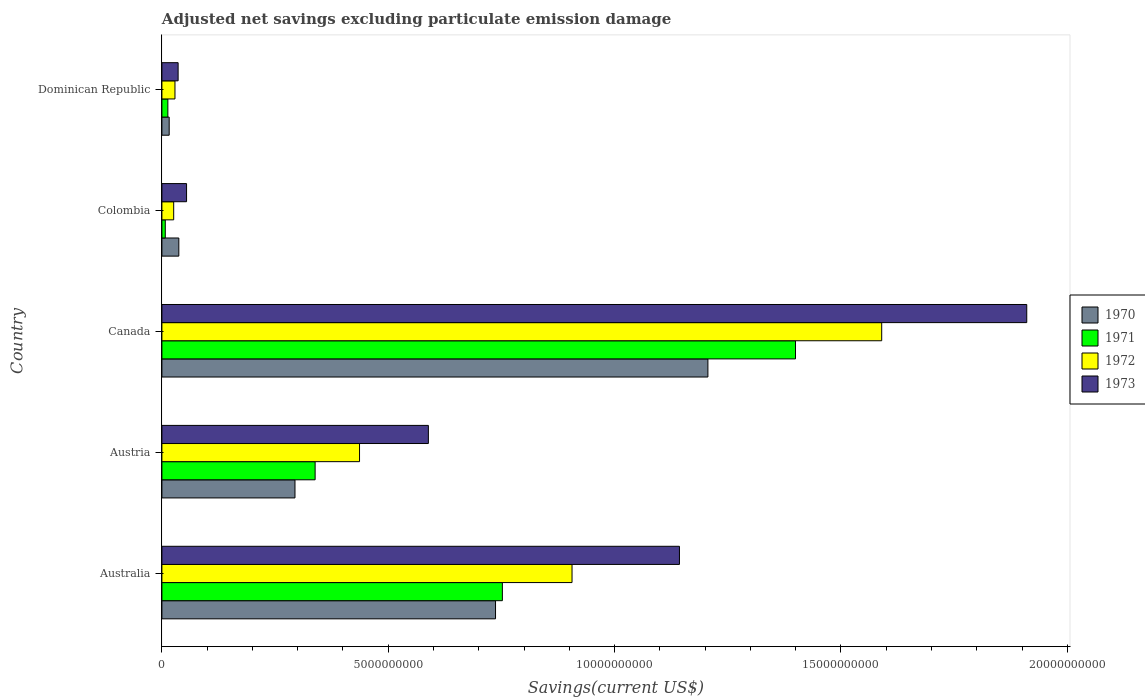How many groups of bars are there?
Provide a short and direct response. 5. Are the number of bars on each tick of the Y-axis equal?
Make the answer very short. Yes. How many bars are there on the 2nd tick from the top?
Provide a succinct answer. 4. How many bars are there on the 2nd tick from the bottom?
Give a very brief answer. 4. What is the label of the 2nd group of bars from the top?
Give a very brief answer. Colombia. What is the adjusted net savings in 1973 in Colombia?
Offer a terse response. 5.45e+08. Across all countries, what is the maximum adjusted net savings in 1973?
Your response must be concise. 1.91e+1. Across all countries, what is the minimum adjusted net savings in 1971?
Your answer should be very brief. 7.46e+07. In which country was the adjusted net savings in 1971 maximum?
Your answer should be compact. Canada. In which country was the adjusted net savings in 1970 minimum?
Your answer should be very brief. Dominican Republic. What is the total adjusted net savings in 1970 in the graph?
Your answer should be compact. 2.29e+1. What is the difference between the adjusted net savings in 1972 in Australia and that in Colombia?
Your answer should be very brief. 8.80e+09. What is the difference between the adjusted net savings in 1971 in Colombia and the adjusted net savings in 1972 in Australia?
Provide a succinct answer. -8.99e+09. What is the average adjusted net savings in 1973 per country?
Keep it short and to the point. 7.47e+09. What is the difference between the adjusted net savings in 1970 and adjusted net savings in 1971 in Colombia?
Make the answer very short. 2.99e+08. What is the ratio of the adjusted net savings in 1970 in Austria to that in Dominican Republic?
Your response must be concise. 18.25. Is the adjusted net savings in 1972 in Austria less than that in Canada?
Make the answer very short. Yes. What is the difference between the highest and the second highest adjusted net savings in 1973?
Offer a very short reply. 7.67e+09. What is the difference between the highest and the lowest adjusted net savings in 1972?
Ensure brevity in your answer.  1.56e+1. In how many countries, is the adjusted net savings in 1973 greater than the average adjusted net savings in 1973 taken over all countries?
Offer a very short reply. 2. Is it the case that in every country, the sum of the adjusted net savings in 1970 and adjusted net savings in 1973 is greater than the sum of adjusted net savings in 1972 and adjusted net savings in 1971?
Your answer should be very brief. No. Are all the bars in the graph horizontal?
Your response must be concise. Yes. Does the graph contain any zero values?
Provide a succinct answer. No. Does the graph contain grids?
Your answer should be compact. No. How many legend labels are there?
Provide a short and direct response. 4. How are the legend labels stacked?
Ensure brevity in your answer.  Vertical. What is the title of the graph?
Your response must be concise. Adjusted net savings excluding particulate emission damage. Does "1998" appear as one of the legend labels in the graph?
Your answer should be very brief. No. What is the label or title of the X-axis?
Provide a succinct answer. Savings(current US$). What is the label or title of the Y-axis?
Your answer should be compact. Country. What is the Savings(current US$) in 1970 in Australia?
Provide a succinct answer. 7.37e+09. What is the Savings(current US$) in 1971 in Australia?
Your answer should be very brief. 7.52e+09. What is the Savings(current US$) in 1972 in Australia?
Keep it short and to the point. 9.06e+09. What is the Savings(current US$) of 1973 in Australia?
Make the answer very short. 1.14e+1. What is the Savings(current US$) in 1970 in Austria?
Keep it short and to the point. 2.94e+09. What is the Savings(current US$) of 1971 in Austria?
Your answer should be compact. 3.38e+09. What is the Savings(current US$) of 1972 in Austria?
Ensure brevity in your answer.  4.37e+09. What is the Savings(current US$) in 1973 in Austria?
Provide a succinct answer. 5.89e+09. What is the Savings(current US$) in 1970 in Canada?
Provide a short and direct response. 1.21e+1. What is the Savings(current US$) of 1971 in Canada?
Provide a short and direct response. 1.40e+1. What is the Savings(current US$) in 1972 in Canada?
Your answer should be compact. 1.59e+1. What is the Savings(current US$) of 1973 in Canada?
Give a very brief answer. 1.91e+1. What is the Savings(current US$) in 1970 in Colombia?
Your response must be concise. 3.74e+08. What is the Savings(current US$) in 1971 in Colombia?
Your response must be concise. 7.46e+07. What is the Savings(current US$) of 1972 in Colombia?
Give a very brief answer. 2.60e+08. What is the Savings(current US$) of 1973 in Colombia?
Your answer should be very brief. 5.45e+08. What is the Savings(current US$) in 1970 in Dominican Republic?
Offer a very short reply. 1.61e+08. What is the Savings(current US$) in 1971 in Dominican Republic?
Make the answer very short. 1.32e+08. What is the Savings(current US$) in 1972 in Dominican Republic?
Keep it short and to the point. 2.89e+08. What is the Savings(current US$) in 1973 in Dominican Republic?
Offer a terse response. 3.58e+08. Across all countries, what is the maximum Savings(current US$) in 1970?
Your answer should be very brief. 1.21e+1. Across all countries, what is the maximum Savings(current US$) of 1971?
Provide a short and direct response. 1.40e+1. Across all countries, what is the maximum Savings(current US$) in 1972?
Keep it short and to the point. 1.59e+1. Across all countries, what is the maximum Savings(current US$) in 1973?
Your response must be concise. 1.91e+1. Across all countries, what is the minimum Savings(current US$) of 1970?
Provide a succinct answer. 1.61e+08. Across all countries, what is the minimum Savings(current US$) in 1971?
Ensure brevity in your answer.  7.46e+07. Across all countries, what is the minimum Savings(current US$) in 1972?
Make the answer very short. 2.60e+08. Across all countries, what is the minimum Savings(current US$) in 1973?
Offer a terse response. 3.58e+08. What is the total Savings(current US$) of 1970 in the graph?
Offer a very short reply. 2.29e+1. What is the total Savings(current US$) of 1971 in the graph?
Your answer should be compact. 2.51e+1. What is the total Savings(current US$) of 1972 in the graph?
Your answer should be very brief. 2.99e+1. What is the total Savings(current US$) in 1973 in the graph?
Your response must be concise. 3.73e+1. What is the difference between the Savings(current US$) in 1970 in Australia and that in Austria?
Ensure brevity in your answer.  4.43e+09. What is the difference between the Savings(current US$) in 1971 in Australia and that in Austria?
Offer a very short reply. 4.14e+09. What is the difference between the Savings(current US$) in 1972 in Australia and that in Austria?
Give a very brief answer. 4.69e+09. What is the difference between the Savings(current US$) in 1973 in Australia and that in Austria?
Give a very brief answer. 5.55e+09. What is the difference between the Savings(current US$) in 1970 in Australia and that in Canada?
Make the answer very short. -4.69e+09. What is the difference between the Savings(current US$) of 1971 in Australia and that in Canada?
Your answer should be compact. -6.48e+09. What is the difference between the Savings(current US$) in 1972 in Australia and that in Canada?
Your response must be concise. -6.84e+09. What is the difference between the Savings(current US$) in 1973 in Australia and that in Canada?
Ensure brevity in your answer.  -7.67e+09. What is the difference between the Savings(current US$) in 1970 in Australia and that in Colombia?
Your response must be concise. 7.00e+09. What is the difference between the Savings(current US$) of 1971 in Australia and that in Colombia?
Your response must be concise. 7.45e+09. What is the difference between the Savings(current US$) in 1972 in Australia and that in Colombia?
Your answer should be very brief. 8.80e+09. What is the difference between the Savings(current US$) in 1973 in Australia and that in Colombia?
Your answer should be very brief. 1.09e+1. What is the difference between the Savings(current US$) of 1970 in Australia and that in Dominican Republic?
Provide a short and direct response. 7.21e+09. What is the difference between the Savings(current US$) of 1971 in Australia and that in Dominican Republic?
Your answer should be compact. 7.39e+09. What is the difference between the Savings(current US$) of 1972 in Australia and that in Dominican Republic?
Make the answer very short. 8.77e+09. What is the difference between the Savings(current US$) in 1973 in Australia and that in Dominican Republic?
Offer a very short reply. 1.11e+1. What is the difference between the Savings(current US$) in 1970 in Austria and that in Canada?
Give a very brief answer. -9.12e+09. What is the difference between the Savings(current US$) in 1971 in Austria and that in Canada?
Offer a terse response. -1.06e+1. What is the difference between the Savings(current US$) in 1972 in Austria and that in Canada?
Ensure brevity in your answer.  -1.15e+1. What is the difference between the Savings(current US$) of 1973 in Austria and that in Canada?
Make the answer very short. -1.32e+1. What is the difference between the Savings(current US$) in 1970 in Austria and that in Colombia?
Offer a terse response. 2.57e+09. What is the difference between the Savings(current US$) in 1971 in Austria and that in Colombia?
Ensure brevity in your answer.  3.31e+09. What is the difference between the Savings(current US$) in 1972 in Austria and that in Colombia?
Keep it short and to the point. 4.11e+09. What is the difference between the Savings(current US$) in 1973 in Austria and that in Colombia?
Provide a short and direct response. 5.34e+09. What is the difference between the Savings(current US$) of 1970 in Austria and that in Dominican Republic?
Offer a terse response. 2.78e+09. What is the difference between the Savings(current US$) in 1971 in Austria and that in Dominican Republic?
Your response must be concise. 3.25e+09. What is the difference between the Savings(current US$) in 1972 in Austria and that in Dominican Republic?
Provide a succinct answer. 4.08e+09. What is the difference between the Savings(current US$) of 1973 in Austria and that in Dominican Republic?
Keep it short and to the point. 5.53e+09. What is the difference between the Savings(current US$) in 1970 in Canada and that in Colombia?
Provide a succinct answer. 1.17e+1. What is the difference between the Savings(current US$) of 1971 in Canada and that in Colombia?
Provide a succinct answer. 1.39e+1. What is the difference between the Savings(current US$) of 1972 in Canada and that in Colombia?
Ensure brevity in your answer.  1.56e+1. What is the difference between the Savings(current US$) in 1973 in Canada and that in Colombia?
Provide a short and direct response. 1.86e+1. What is the difference between the Savings(current US$) of 1970 in Canada and that in Dominican Republic?
Your response must be concise. 1.19e+1. What is the difference between the Savings(current US$) in 1971 in Canada and that in Dominican Republic?
Offer a terse response. 1.39e+1. What is the difference between the Savings(current US$) of 1972 in Canada and that in Dominican Republic?
Provide a short and direct response. 1.56e+1. What is the difference between the Savings(current US$) in 1973 in Canada and that in Dominican Republic?
Provide a short and direct response. 1.87e+1. What is the difference between the Savings(current US$) in 1970 in Colombia and that in Dominican Republic?
Give a very brief answer. 2.13e+08. What is the difference between the Savings(current US$) of 1971 in Colombia and that in Dominican Republic?
Provide a short and direct response. -5.69e+07. What is the difference between the Savings(current US$) in 1972 in Colombia and that in Dominican Republic?
Give a very brief answer. -2.84e+07. What is the difference between the Savings(current US$) in 1973 in Colombia and that in Dominican Republic?
Give a very brief answer. 1.87e+08. What is the difference between the Savings(current US$) in 1970 in Australia and the Savings(current US$) in 1971 in Austria?
Provide a short and direct response. 3.98e+09. What is the difference between the Savings(current US$) in 1970 in Australia and the Savings(current US$) in 1972 in Austria?
Make the answer very short. 3.00e+09. What is the difference between the Savings(current US$) in 1970 in Australia and the Savings(current US$) in 1973 in Austria?
Provide a short and direct response. 1.48e+09. What is the difference between the Savings(current US$) of 1971 in Australia and the Savings(current US$) of 1972 in Austria?
Ensure brevity in your answer.  3.16e+09. What is the difference between the Savings(current US$) of 1971 in Australia and the Savings(current US$) of 1973 in Austria?
Offer a terse response. 1.63e+09. What is the difference between the Savings(current US$) in 1972 in Australia and the Savings(current US$) in 1973 in Austria?
Provide a short and direct response. 3.17e+09. What is the difference between the Savings(current US$) of 1970 in Australia and the Savings(current US$) of 1971 in Canada?
Your response must be concise. -6.63e+09. What is the difference between the Savings(current US$) in 1970 in Australia and the Savings(current US$) in 1972 in Canada?
Offer a very short reply. -8.53e+09. What is the difference between the Savings(current US$) of 1970 in Australia and the Savings(current US$) of 1973 in Canada?
Ensure brevity in your answer.  -1.17e+1. What is the difference between the Savings(current US$) of 1971 in Australia and the Savings(current US$) of 1972 in Canada?
Provide a succinct answer. -8.38e+09. What is the difference between the Savings(current US$) in 1971 in Australia and the Savings(current US$) in 1973 in Canada?
Your answer should be compact. -1.16e+1. What is the difference between the Savings(current US$) of 1972 in Australia and the Savings(current US$) of 1973 in Canada?
Offer a terse response. -1.00e+1. What is the difference between the Savings(current US$) of 1970 in Australia and the Savings(current US$) of 1971 in Colombia?
Provide a short and direct response. 7.30e+09. What is the difference between the Savings(current US$) of 1970 in Australia and the Savings(current US$) of 1972 in Colombia?
Keep it short and to the point. 7.11e+09. What is the difference between the Savings(current US$) of 1970 in Australia and the Savings(current US$) of 1973 in Colombia?
Keep it short and to the point. 6.83e+09. What is the difference between the Savings(current US$) of 1971 in Australia and the Savings(current US$) of 1972 in Colombia?
Offer a very short reply. 7.26e+09. What is the difference between the Savings(current US$) of 1971 in Australia and the Savings(current US$) of 1973 in Colombia?
Offer a very short reply. 6.98e+09. What is the difference between the Savings(current US$) in 1972 in Australia and the Savings(current US$) in 1973 in Colombia?
Make the answer very short. 8.51e+09. What is the difference between the Savings(current US$) of 1970 in Australia and the Savings(current US$) of 1971 in Dominican Republic?
Offer a very short reply. 7.24e+09. What is the difference between the Savings(current US$) in 1970 in Australia and the Savings(current US$) in 1972 in Dominican Republic?
Ensure brevity in your answer.  7.08e+09. What is the difference between the Savings(current US$) in 1970 in Australia and the Savings(current US$) in 1973 in Dominican Republic?
Your answer should be very brief. 7.01e+09. What is the difference between the Savings(current US$) in 1971 in Australia and the Savings(current US$) in 1972 in Dominican Republic?
Give a very brief answer. 7.23e+09. What is the difference between the Savings(current US$) of 1971 in Australia and the Savings(current US$) of 1973 in Dominican Republic?
Offer a terse response. 7.16e+09. What is the difference between the Savings(current US$) of 1972 in Australia and the Savings(current US$) of 1973 in Dominican Republic?
Your response must be concise. 8.70e+09. What is the difference between the Savings(current US$) of 1970 in Austria and the Savings(current US$) of 1971 in Canada?
Your response must be concise. -1.11e+1. What is the difference between the Savings(current US$) of 1970 in Austria and the Savings(current US$) of 1972 in Canada?
Provide a succinct answer. -1.30e+1. What is the difference between the Savings(current US$) of 1970 in Austria and the Savings(current US$) of 1973 in Canada?
Your answer should be very brief. -1.62e+1. What is the difference between the Savings(current US$) of 1971 in Austria and the Savings(current US$) of 1972 in Canada?
Make the answer very short. -1.25e+1. What is the difference between the Savings(current US$) of 1971 in Austria and the Savings(current US$) of 1973 in Canada?
Give a very brief answer. -1.57e+1. What is the difference between the Savings(current US$) in 1972 in Austria and the Savings(current US$) in 1973 in Canada?
Provide a succinct answer. -1.47e+1. What is the difference between the Savings(current US$) in 1970 in Austria and the Savings(current US$) in 1971 in Colombia?
Keep it short and to the point. 2.87e+09. What is the difference between the Savings(current US$) in 1970 in Austria and the Savings(current US$) in 1972 in Colombia?
Provide a succinct answer. 2.68e+09. What is the difference between the Savings(current US$) of 1970 in Austria and the Savings(current US$) of 1973 in Colombia?
Offer a very short reply. 2.40e+09. What is the difference between the Savings(current US$) in 1971 in Austria and the Savings(current US$) in 1972 in Colombia?
Offer a very short reply. 3.12e+09. What is the difference between the Savings(current US$) in 1971 in Austria and the Savings(current US$) in 1973 in Colombia?
Provide a succinct answer. 2.84e+09. What is the difference between the Savings(current US$) of 1972 in Austria and the Savings(current US$) of 1973 in Colombia?
Make the answer very short. 3.82e+09. What is the difference between the Savings(current US$) of 1970 in Austria and the Savings(current US$) of 1971 in Dominican Republic?
Provide a short and direct response. 2.81e+09. What is the difference between the Savings(current US$) of 1970 in Austria and the Savings(current US$) of 1972 in Dominican Republic?
Provide a succinct answer. 2.65e+09. What is the difference between the Savings(current US$) in 1970 in Austria and the Savings(current US$) in 1973 in Dominican Republic?
Your answer should be compact. 2.58e+09. What is the difference between the Savings(current US$) of 1971 in Austria and the Savings(current US$) of 1972 in Dominican Republic?
Offer a terse response. 3.10e+09. What is the difference between the Savings(current US$) in 1971 in Austria and the Savings(current US$) in 1973 in Dominican Republic?
Keep it short and to the point. 3.03e+09. What is the difference between the Savings(current US$) of 1972 in Austria and the Savings(current US$) of 1973 in Dominican Republic?
Your response must be concise. 4.01e+09. What is the difference between the Savings(current US$) in 1970 in Canada and the Savings(current US$) in 1971 in Colombia?
Your answer should be very brief. 1.20e+1. What is the difference between the Savings(current US$) in 1970 in Canada and the Savings(current US$) in 1972 in Colombia?
Your answer should be compact. 1.18e+1. What is the difference between the Savings(current US$) of 1970 in Canada and the Savings(current US$) of 1973 in Colombia?
Your answer should be very brief. 1.15e+1. What is the difference between the Savings(current US$) of 1971 in Canada and the Savings(current US$) of 1972 in Colombia?
Keep it short and to the point. 1.37e+1. What is the difference between the Savings(current US$) of 1971 in Canada and the Savings(current US$) of 1973 in Colombia?
Your answer should be compact. 1.35e+1. What is the difference between the Savings(current US$) in 1972 in Canada and the Savings(current US$) in 1973 in Colombia?
Offer a very short reply. 1.54e+1. What is the difference between the Savings(current US$) in 1970 in Canada and the Savings(current US$) in 1971 in Dominican Republic?
Keep it short and to the point. 1.19e+1. What is the difference between the Savings(current US$) in 1970 in Canada and the Savings(current US$) in 1972 in Dominican Republic?
Your answer should be very brief. 1.18e+1. What is the difference between the Savings(current US$) in 1970 in Canada and the Savings(current US$) in 1973 in Dominican Republic?
Give a very brief answer. 1.17e+1. What is the difference between the Savings(current US$) in 1971 in Canada and the Savings(current US$) in 1972 in Dominican Republic?
Offer a very short reply. 1.37e+1. What is the difference between the Savings(current US$) of 1971 in Canada and the Savings(current US$) of 1973 in Dominican Republic?
Ensure brevity in your answer.  1.36e+1. What is the difference between the Savings(current US$) of 1972 in Canada and the Savings(current US$) of 1973 in Dominican Republic?
Offer a very short reply. 1.55e+1. What is the difference between the Savings(current US$) in 1970 in Colombia and the Savings(current US$) in 1971 in Dominican Republic?
Your response must be concise. 2.42e+08. What is the difference between the Savings(current US$) in 1970 in Colombia and the Savings(current US$) in 1972 in Dominican Republic?
Give a very brief answer. 8.52e+07. What is the difference between the Savings(current US$) in 1970 in Colombia and the Savings(current US$) in 1973 in Dominican Republic?
Offer a very short reply. 1.57e+07. What is the difference between the Savings(current US$) in 1971 in Colombia and the Savings(current US$) in 1972 in Dominican Republic?
Your answer should be very brief. -2.14e+08. What is the difference between the Savings(current US$) of 1971 in Colombia and the Savings(current US$) of 1973 in Dominican Republic?
Keep it short and to the point. -2.84e+08. What is the difference between the Savings(current US$) of 1972 in Colombia and the Savings(current US$) of 1973 in Dominican Republic?
Your response must be concise. -9.79e+07. What is the average Savings(current US$) of 1970 per country?
Your answer should be very brief. 4.58e+09. What is the average Savings(current US$) in 1971 per country?
Your answer should be compact. 5.02e+09. What is the average Savings(current US$) of 1972 per country?
Your answer should be compact. 5.97e+09. What is the average Savings(current US$) of 1973 per country?
Offer a terse response. 7.47e+09. What is the difference between the Savings(current US$) in 1970 and Savings(current US$) in 1971 in Australia?
Your response must be concise. -1.51e+08. What is the difference between the Savings(current US$) in 1970 and Savings(current US$) in 1972 in Australia?
Ensure brevity in your answer.  -1.69e+09. What is the difference between the Savings(current US$) of 1970 and Savings(current US$) of 1973 in Australia?
Give a very brief answer. -4.06e+09. What is the difference between the Savings(current US$) of 1971 and Savings(current US$) of 1972 in Australia?
Keep it short and to the point. -1.54e+09. What is the difference between the Savings(current US$) in 1971 and Savings(current US$) in 1973 in Australia?
Your response must be concise. -3.91e+09. What is the difference between the Savings(current US$) of 1972 and Savings(current US$) of 1973 in Australia?
Make the answer very short. -2.37e+09. What is the difference between the Savings(current US$) in 1970 and Savings(current US$) in 1971 in Austria?
Offer a terse response. -4.45e+08. What is the difference between the Savings(current US$) of 1970 and Savings(current US$) of 1972 in Austria?
Offer a terse response. -1.43e+09. What is the difference between the Savings(current US$) in 1970 and Savings(current US$) in 1973 in Austria?
Your answer should be compact. -2.95e+09. What is the difference between the Savings(current US$) of 1971 and Savings(current US$) of 1972 in Austria?
Offer a terse response. -9.81e+08. What is the difference between the Savings(current US$) of 1971 and Savings(current US$) of 1973 in Austria?
Your answer should be very brief. -2.50e+09. What is the difference between the Savings(current US$) in 1972 and Savings(current US$) in 1973 in Austria?
Make the answer very short. -1.52e+09. What is the difference between the Savings(current US$) in 1970 and Savings(current US$) in 1971 in Canada?
Provide a succinct answer. -1.94e+09. What is the difference between the Savings(current US$) in 1970 and Savings(current US$) in 1972 in Canada?
Offer a very short reply. -3.84e+09. What is the difference between the Savings(current US$) of 1970 and Savings(current US$) of 1973 in Canada?
Offer a very short reply. -7.04e+09. What is the difference between the Savings(current US$) of 1971 and Savings(current US$) of 1972 in Canada?
Keep it short and to the point. -1.90e+09. What is the difference between the Savings(current US$) of 1971 and Savings(current US$) of 1973 in Canada?
Make the answer very short. -5.11e+09. What is the difference between the Savings(current US$) of 1972 and Savings(current US$) of 1973 in Canada?
Offer a very short reply. -3.20e+09. What is the difference between the Savings(current US$) of 1970 and Savings(current US$) of 1971 in Colombia?
Offer a terse response. 2.99e+08. What is the difference between the Savings(current US$) in 1970 and Savings(current US$) in 1972 in Colombia?
Offer a very short reply. 1.14e+08. What is the difference between the Savings(current US$) of 1970 and Savings(current US$) of 1973 in Colombia?
Provide a short and direct response. -1.71e+08. What is the difference between the Savings(current US$) of 1971 and Savings(current US$) of 1972 in Colombia?
Your response must be concise. -1.86e+08. What is the difference between the Savings(current US$) in 1971 and Savings(current US$) in 1973 in Colombia?
Offer a terse response. -4.70e+08. What is the difference between the Savings(current US$) in 1972 and Savings(current US$) in 1973 in Colombia?
Offer a terse response. -2.85e+08. What is the difference between the Savings(current US$) in 1970 and Savings(current US$) in 1971 in Dominican Republic?
Your response must be concise. 2.96e+07. What is the difference between the Savings(current US$) in 1970 and Savings(current US$) in 1972 in Dominican Republic?
Give a very brief answer. -1.28e+08. What is the difference between the Savings(current US$) in 1970 and Savings(current US$) in 1973 in Dominican Republic?
Ensure brevity in your answer.  -1.97e+08. What is the difference between the Savings(current US$) of 1971 and Savings(current US$) of 1972 in Dominican Republic?
Offer a terse response. -1.57e+08. What is the difference between the Savings(current US$) in 1971 and Savings(current US$) in 1973 in Dominican Republic?
Your response must be concise. -2.27e+08. What is the difference between the Savings(current US$) of 1972 and Savings(current US$) of 1973 in Dominican Republic?
Make the answer very short. -6.95e+07. What is the ratio of the Savings(current US$) of 1970 in Australia to that in Austria?
Give a very brief answer. 2.51. What is the ratio of the Savings(current US$) in 1971 in Australia to that in Austria?
Offer a terse response. 2.22. What is the ratio of the Savings(current US$) of 1972 in Australia to that in Austria?
Provide a short and direct response. 2.08. What is the ratio of the Savings(current US$) of 1973 in Australia to that in Austria?
Your response must be concise. 1.94. What is the ratio of the Savings(current US$) of 1970 in Australia to that in Canada?
Your answer should be compact. 0.61. What is the ratio of the Savings(current US$) of 1971 in Australia to that in Canada?
Provide a short and direct response. 0.54. What is the ratio of the Savings(current US$) in 1972 in Australia to that in Canada?
Your response must be concise. 0.57. What is the ratio of the Savings(current US$) in 1973 in Australia to that in Canada?
Offer a terse response. 0.6. What is the ratio of the Savings(current US$) of 1970 in Australia to that in Colombia?
Offer a terse response. 19.71. What is the ratio of the Savings(current US$) in 1971 in Australia to that in Colombia?
Offer a very short reply. 100.8. What is the ratio of the Savings(current US$) of 1972 in Australia to that in Colombia?
Ensure brevity in your answer.  34.81. What is the ratio of the Savings(current US$) of 1973 in Australia to that in Colombia?
Provide a short and direct response. 20.98. What is the ratio of the Savings(current US$) of 1970 in Australia to that in Dominican Republic?
Provide a short and direct response. 45.75. What is the ratio of the Savings(current US$) of 1971 in Australia to that in Dominican Republic?
Provide a short and direct response. 57.18. What is the ratio of the Savings(current US$) in 1972 in Australia to that in Dominican Republic?
Offer a very short reply. 31.38. What is the ratio of the Savings(current US$) of 1973 in Australia to that in Dominican Republic?
Ensure brevity in your answer.  31.92. What is the ratio of the Savings(current US$) of 1970 in Austria to that in Canada?
Offer a terse response. 0.24. What is the ratio of the Savings(current US$) of 1971 in Austria to that in Canada?
Offer a terse response. 0.24. What is the ratio of the Savings(current US$) in 1972 in Austria to that in Canada?
Offer a terse response. 0.27. What is the ratio of the Savings(current US$) in 1973 in Austria to that in Canada?
Provide a short and direct response. 0.31. What is the ratio of the Savings(current US$) of 1970 in Austria to that in Colombia?
Your answer should be very brief. 7.86. What is the ratio of the Savings(current US$) of 1971 in Austria to that in Colombia?
Your answer should be compact. 45.37. What is the ratio of the Savings(current US$) in 1972 in Austria to that in Colombia?
Your answer should be very brief. 16.77. What is the ratio of the Savings(current US$) of 1973 in Austria to that in Colombia?
Offer a very short reply. 10.8. What is the ratio of the Savings(current US$) in 1970 in Austria to that in Dominican Republic?
Ensure brevity in your answer.  18.25. What is the ratio of the Savings(current US$) in 1971 in Austria to that in Dominican Republic?
Keep it short and to the point. 25.73. What is the ratio of the Savings(current US$) in 1972 in Austria to that in Dominican Republic?
Your answer should be very brief. 15.12. What is the ratio of the Savings(current US$) in 1973 in Austria to that in Dominican Republic?
Keep it short and to the point. 16.43. What is the ratio of the Savings(current US$) of 1970 in Canada to that in Colombia?
Make the answer very short. 32.26. What is the ratio of the Savings(current US$) of 1971 in Canada to that in Colombia?
Keep it short and to the point. 187.59. What is the ratio of the Savings(current US$) in 1972 in Canada to that in Colombia?
Ensure brevity in your answer.  61.09. What is the ratio of the Savings(current US$) of 1973 in Canada to that in Colombia?
Offer a terse response. 35.07. What is the ratio of the Savings(current US$) in 1970 in Canada to that in Dominican Republic?
Provide a short and direct response. 74.87. What is the ratio of the Savings(current US$) in 1971 in Canada to that in Dominican Republic?
Your answer should be very brief. 106.4. What is the ratio of the Savings(current US$) of 1972 in Canada to that in Dominican Republic?
Give a very brief answer. 55.08. What is the ratio of the Savings(current US$) of 1973 in Canada to that in Dominican Republic?
Your answer should be compact. 53.33. What is the ratio of the Savings(current US$) of 1970 in Colombia to that in Dominican Republic?
Ensure brevity in your answer.  2.32. What is the ratio of the Savings(current US$) of 1971 in Colombia to that in Dominican Republic?
Give a very brief answer. 0.57. What is the ratio of the Savings(current US$) in 1972 in Colombia to that in Dominican Republic?
Provide a succinct answer. 0.9. What is the ratio of the Savings(current US$) of 1973 in Colombia to that in Dominican Republic?
Provide a short and direct response. 1.52. What is the difference between the highest and the second highest Savings(current US$) in 1970?
Provide a succinct answer. 4.69e+09. What is the difference between the highest and the second highest Savings(current US$) of 1971?
Your answer should be compact. 6.48e+09. What is the difference between the highest and the second highest Savings(current US$) of 1972?
Provide a short and direct response. 6.84e+09. What is the difference between the highest and the second highest Savings(current US$) of 1973?
Offer a terse response. 7.67e+09. What is the difference between the highest and the lowest Savings(current US$) in 1970?
Offer a terse response. 1.19e+1. What is the difference between the highest and the lowest Savings(current US$) in 1971?
Your answer should be very brief. 1.39e+1. What is the difference between the highest and the lowest Savings(current US$) in 1972?
Your response must be concise. 1.56e+1. What is the difference between the highest and the lowest Savings(current US$) of 1973?
Make the answer very short. 1.87e+1. 